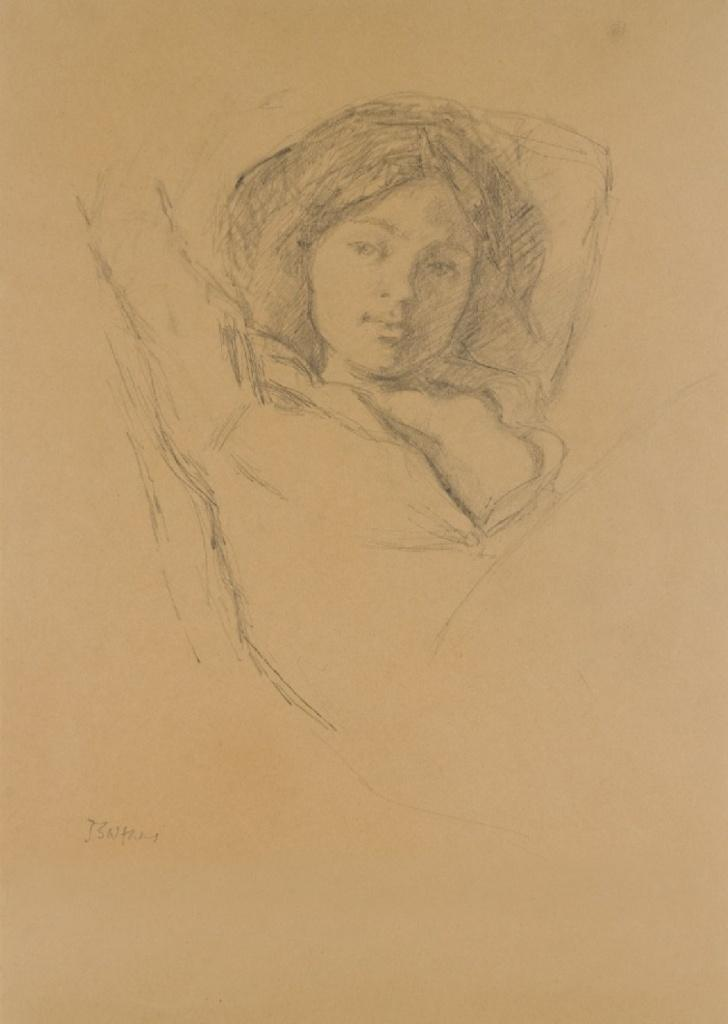What is the primary color of the sheet in the image? The sheet in the image is cream-colored. What is depicted on the sheet? There is a pencil sketch of a woman on the sheet. What type of whistle is being used by the woman in the pencil sketch? There is no whistle present in the image, as the sketch is of a woman and not an activity or object. 